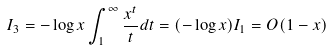<formula> <loc_0><loc_0><loc_500><loc_500>I _ { 3 } & = - \log x \int _ { 1 } ^ { \infty } \frac { x ^ { t } } { t } d t = ( - \log x ) I _ { 1 } = O ( 1 - x )</formula> 